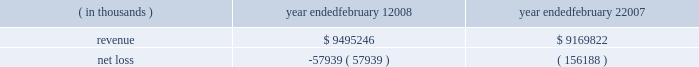For intangible assets subject to amortization , the estimated aggregate amortization expense for each of the five succeeding fiscal years is as follows : 2009 - $ 41.1 million , 2010 - $ 27.3 million , 2011 - $ 20.9 million , 2012 - $ 17.0 million , and 2013 - $ 12.0 million .
Fees and expenses related to the merger totaled $ 102.6 million , principally consisting of investment banking fees , legal fees and stock compensation ( $ 39.4 million as further discussed in note 10 ) , and are reflected in the 2007 results of operations .
Capitalized debt issuance costs as of the merger date of $ 87.4 million for merger-related financing were reflected in other long- term assets in the consolidated balance sheet .
The following represents the unaudited pro forma results of the company 2019s consolidated operations as if the merger had occurred on february 3 , 2007 and february 4 , 2006 , respectively , after giving effect to certain adjustments , including the depreciation and amortization of the assets acquired based on their estimated fair values and changes in interest expense resulting from changes in consolidated debt ( in thousands ) : ( in thousands ) year ended february 1 , year ended february 2 .
The pro forma information does not purport to be indicative of what the company 2019s results of operations would have been if the acquisition had in fact occurred at the beginning of the periods presented , and is not intended to be a projection of the company 2019s future results of operations .
Subsequent to the announcement of the merger agreement , the company and its directors , along with other parties , were named in seven putative class actions filed in tennessee state courts alleging claims for breach of fiduciary duty arising out of the proposed merger , all as described more fully under 201clegal proceedings 201d in note 8 below .
Strategic initiatives during 2006 , the company began implementing certain strategic initiatives related to its historical inventory management and real estate strategies , as more fully described below .
Inventory management in november 2006 , the company undertook an initiative to discontinue its historical inventory packaway model for virtually all merchandise by the end of fiscal 2007 .
Under the packaway model , certain unsold inventory items ( primarily seasonal merchandise ) were stored on-site and returned to the sales floor until the items were eventually sold , damaged or discarded .
Through end-of-season and other markdowns , this initiative resulted in the elimination of seasonal , home products and basic clothing packaway merchandise to allow for increased levels of newer , current-season merchandise .
In connection with this strategic change , in the third quarter of 2006 the company recorded a reserve for lower of cost or market inventory .
What is the growth rate of revenue from 2007 to 2008? 
Computations: ((9495246 - 9169822) / 9169822)
Answer: 0.03549. 